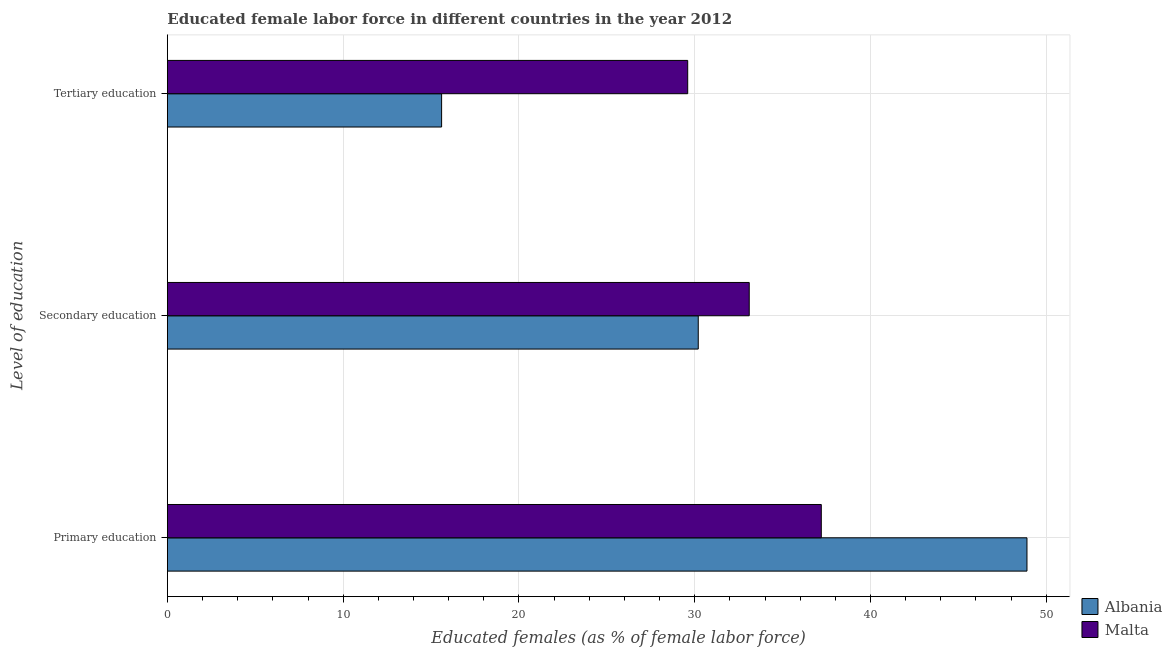How many groups of bars are there?
Your response must be concise. 3. Are the number of bars per tick equal to the number of legend labels?
Offer a terse response. Yes. How many bars are there on the 2nd tick from the top?
Provide a short and direct response. 2. What is the label of the 1st group of bars from the top?
Make the answer very short. Tertiary education. What is the percentage of female labor force who received secondary education in Albania?
Your answer should be compact. 30.2. Across all countries, what is the maximum percentage of female labor force who received primary education?
Provide a short and direct response. 48.9. Across all countries, what is the minimum percentage of female labor force who received secondary education?
Your answer should be compact. 30.2. In which country was the percentage of female labor force who received primary education maximum?
Ensure brevity in your answer.  Albania. In which country was the percentage of female labor force who received tertiary education minimum?
Your answer should be compact. Albania. What is the total percentage of female labor force who received secondary education in the graph?
Provide a short and direct response. 63.3. What is the difference between the percentage of female labor force who received secondary education in Malta and that in Albania?
Ensure brevity in your answer.  2.9. What is the difference between the percentage of female labor force who received tertiary education in Malta and the percentage of female labor force who received primary education in Albania?
Your answer should be very brief. -19.3. What is the average percentage of female labor force who received primary education per country?
Provide a short and direct response. 43.05. What is the difference between the percentage of female labor force who received tertiary education and percentage of female labor force who received primary education in Malta?
Your answer should be compact. -7.6. In how many countries, is the percentage of female labor force who received tertiary education greater than 4 %?
Provide a succinct answer. 2. What is the ratio of the percentage of female labor force who received tertiary education in Albania to that in Malta?
Your response must be concise. 0.53. What is the difference between the highest and the second highest percentage of female labor force who received secondary education?
Your answer should be very brief. 2.9. What is the difference between the highest and the lowest percentage of female labor force who received primary education?
Offer a very short reply. 11.7. Is the sum of the percentage of female labor force who received tertiary education in Malta and Albania greater than the maximum percentage of female labor force who received primary education across all countries?
Your answer should be compact. No. What does the 1st bar from the top in Primary education represents?
Provide a succinct answer. Malta. What does the 1st bar from the bottom in Primary education represents?
Provide a short and direct response. Albania. How many bars are there?
Your response must be concise. 6. Are all the bars in the graph horizontal?
Keep it short and to the point. Yes. Where does the legend appear in the graph?
Keep it short and to the point. Bottom right. How many legend labels are there?
Make the answer very short. 2. How are the legend labels stacked?
Your answer should be compact. Vertical. What is the title of the graph?
Give a very brief answer. Educated female labor force in different countries in the year 2012. What is the label or title of the X-axis?
Ensure brevity in your answer.  Educated females (as % of female labor force). What is the label or title of the Y-axis?
Provide a succinct answer. Level of education. What is the Educated females (as % of female labor force) in Albania in Primary education?
Ensure brevity in your answer.  48.9. What is the Educated females (as % of female labor force) of Malta in Primary education?
Your response must be concise. 37.2. What is the Educated females (as % of female labor force) of Albania in Secondary education?
Provide a short and direct response. 30.2. What is the Educated females (as % of female labor force) of Malta in Secondary education?
Ensure brevity in your answer.  33.1. What is the Educated females (as % of female labor force) in Albania in Tertiary education?
Your answer should be compact. 15.6. What is the Educated females (as % of female labor force) of Malta in Tertiary education?
Your answer should be very brief. 29.6. Across all Level of education, what is the maximum Educated females (as % of female labor force) in Albania?
Your response must be concise. 48.9. Across all Level of education, what is the maximum Educated females (as % of female labor force) of Malta?
Offer a very short reply. 37.2. Across all Level of education, what is the minimum Educated females (as % of female labor force) in Albania?
Offer a terse response. 15.6. Across all Level of education, what is the minimum Educated females (as % of female labor force) of Malta?
Your answer should be very brief. 29.6. What is the total Educated females (as % of female labor force) of Albania in the graph?
Keep it short and to the point. 94.7. What is the total Educated females (as % of female labor force) in Malta in the graph?
Provide a succinct answer. 99.9. What is the difference between the Educated females (as % of female labor force) in Albania in Primary education and that in Tertiary education?
Ensure brevity in your answer.  33.3. What is the difference between the Educated females (as % of female labor force) of Malta in Primary education and that in Tertiary education?
Your response must be concise. 7.6. What is the difference between the Educated females (as % of female labor force) of Albania in Secondary education and that in Tertiary education?
Offer a terse response. 14.6. What is the difference between the Educated females (as % of female labor force) of Malta in Secondary education and that in Tertiary education?
Give a very brief answer. 3.5. What is the difference between the Educated females (as % of female labor force) of Albania in Primary education and the Educated females (as % of female labor force) of Malta in Secondary education?
Make the answer very short. 15.8. What is the difference between the Educated females (as % of female labor force) of Albania in Primary education and the Educated females (as % of female labor force) of Malta in Tertiary education?
Provide a short and direct response. 19.3. What is the difference between the Educated females (as % of female labor force) in Albania in Secondary education and the Educated females (as % of female labor force) in Malta in Tertiary education?
Your response must be concise. 0.6. What is the average Educated females (as % of female labor force) of Albania per Level of education?
Your answer should be compact. 31.57. What is the average Educated females (as % of female labor force) in Malta per Level of education?
Offer a terse response. 33.3. What is the difference between the Educated females (as % of female labor force) in Albania and Educated females (as % of female labor force) in Malta in Primary education?
Make the answer very short. 11.7. What is the ratio of the Educated females (as % of female labor force) in Albania in Primary education to that in Secondary education?
Offer a terse response. 1.62. What is the ratio of the Educated females (as % of female labor force) in Malta in Primary education to that in Secondary education?
Offer a very short reply. 1.12. What is the ratio of the Educated females (as % of female labor force) in Albania in Primary education to that in Tertiary education?
Give a very brief answer. 3.13. What is the ratio of the Educated females (as % of female labor force) of Malta in Primary education to that in Tertiary education?
Your answer should be compact. 1.26. What is the ratio of the Educated females (as % of female labor force) of Albania in Secondary education to that in Tertiary education?
Your response must be concise. 1.94. What is the ratio of the Educated females (as % of female labor force) in Malta in Secondary education to that in Tertiary education?
Your answer should be compact. 1.12. What is the difference between the highest and the second highest Educated females (as % of female labor force) of Albania?
Your response must be concise. 18.7. What is the difference between the highest and the second highest Educated females (as % of female labor force) of Malta?
Provide a short and direct response. 4.1. What is the difference between the highest and the lowest Educated females (as % of female labor force) in Albania?
Offer a very short reply. 33.3. 